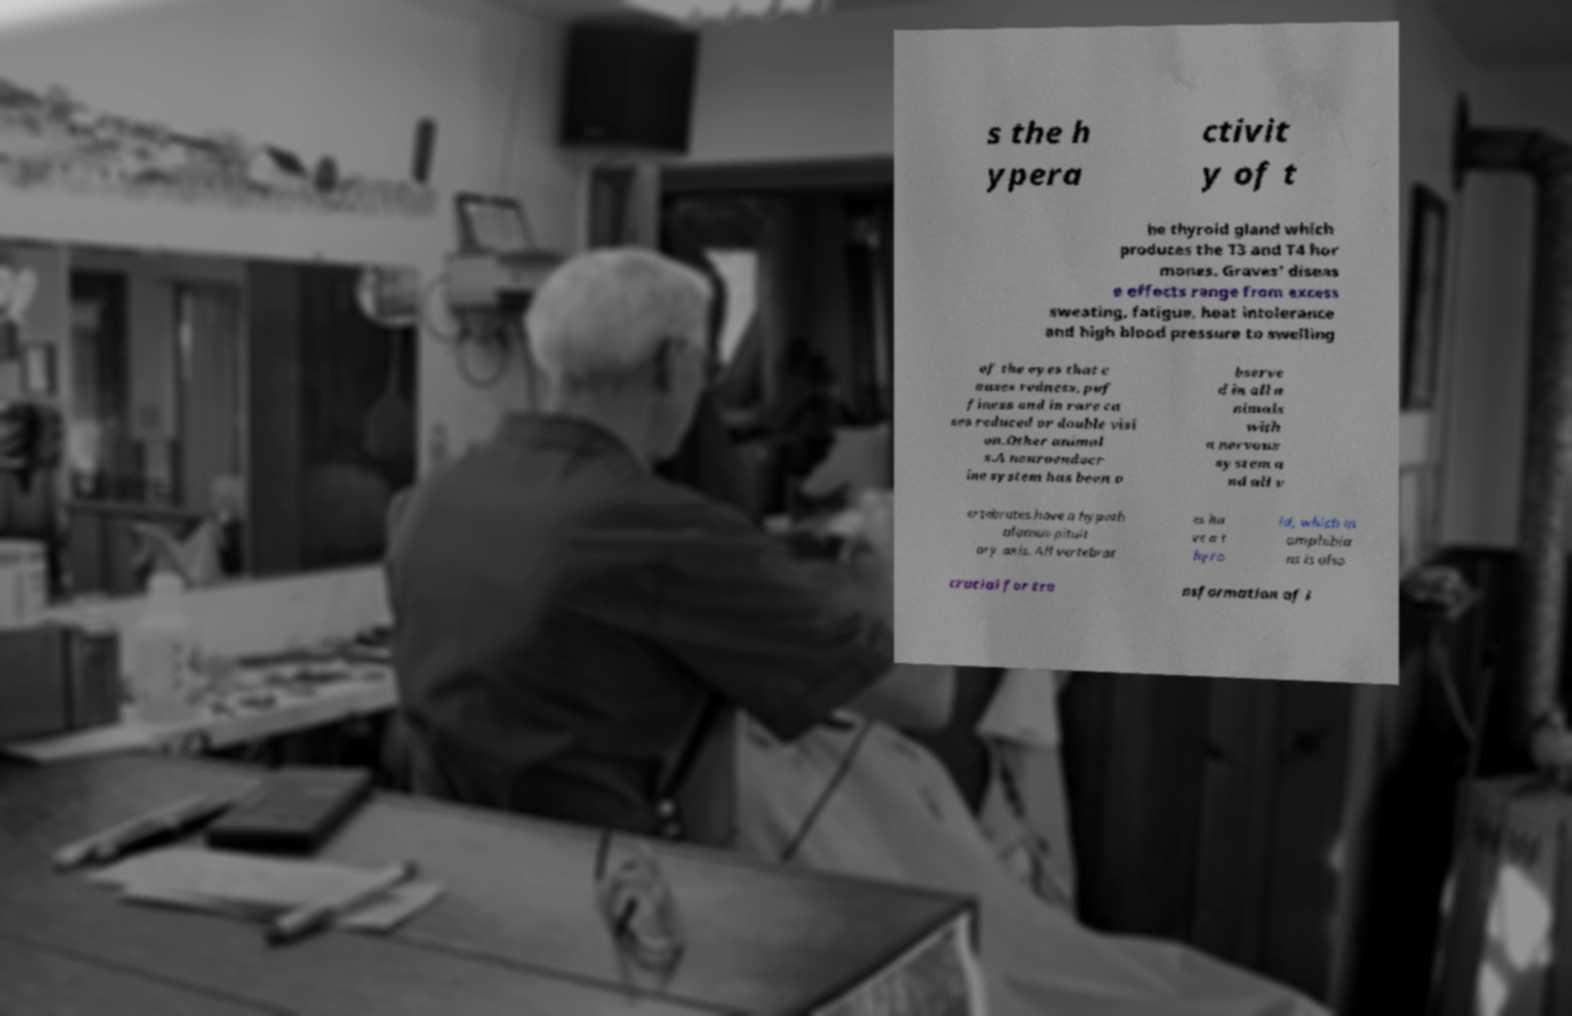Please read and relay the text visible in this image. What does it say? s the h ypera ctivit y of t he thyroid gland which produces the T3 and T4 hor mones. Graves' diseas e effects range from excess sweating, fatigue, heat intolerance and high blood pressure to swelling of the eyes that c auses redness, puf finess and in rare ca ses reduced or double visi on.Other animal s.A neuroendocr ine system has been o bserve d in all a nimals with a nervous system a nd all v ertebrates have a hypoth alamus-pituit ary axis. All vertebrat es ha ve a t hyro id, which in amphibia ns is also crucial for tra nsformation of l 